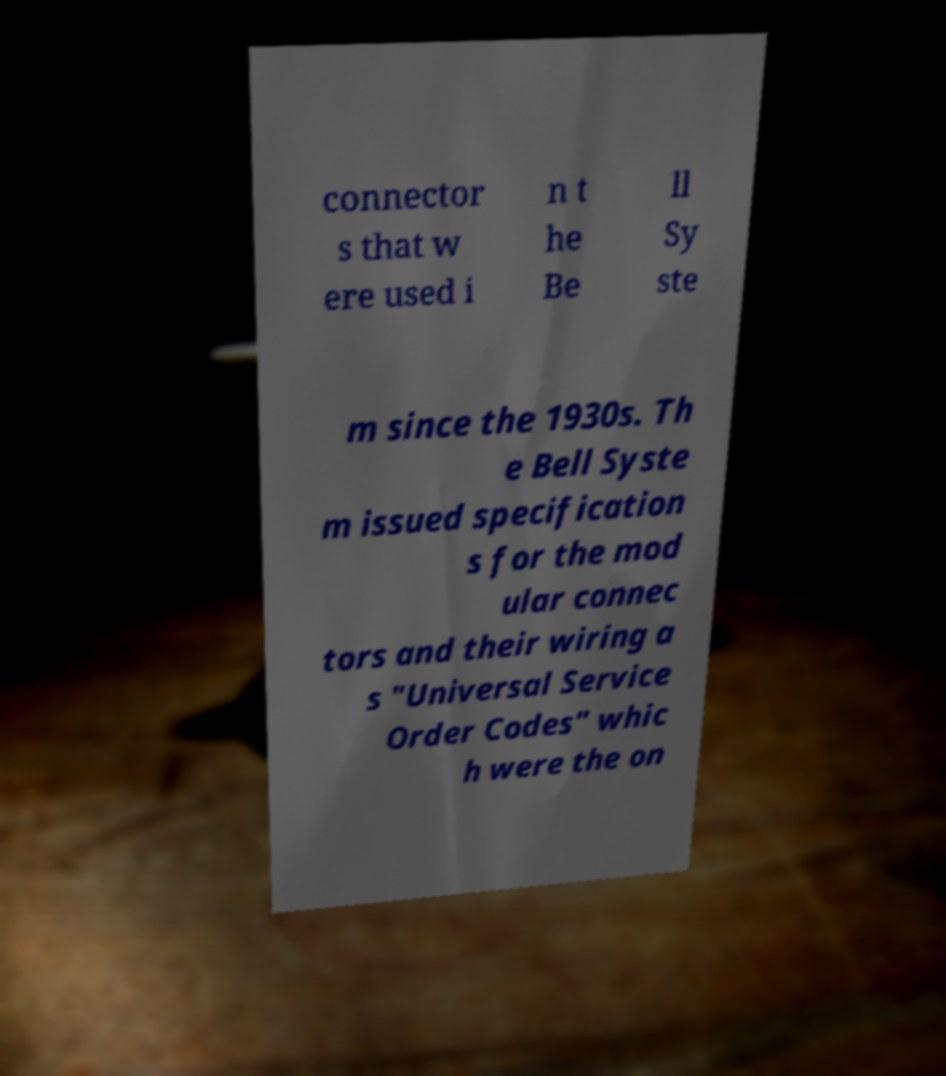There's text embedded in this image that I need extracted. Can you transcribe it verbatim? connector s that w ere used i n t he Be ll Sy ste m since the 1930s. Th e Bell Syste m issued specification s for the mod ular connec tors and their wiring a s "Universal Service Order Codes" whic h were the on 